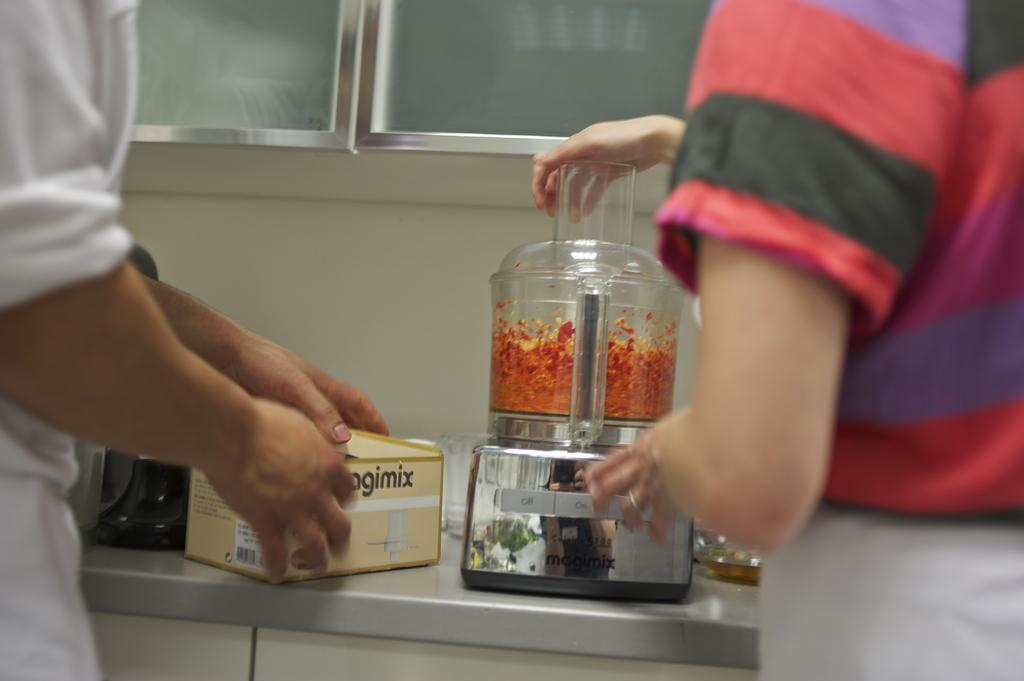<image>
Offer a succinct explanation of the picture presented. A Magimix food processor is being used on carrots. 